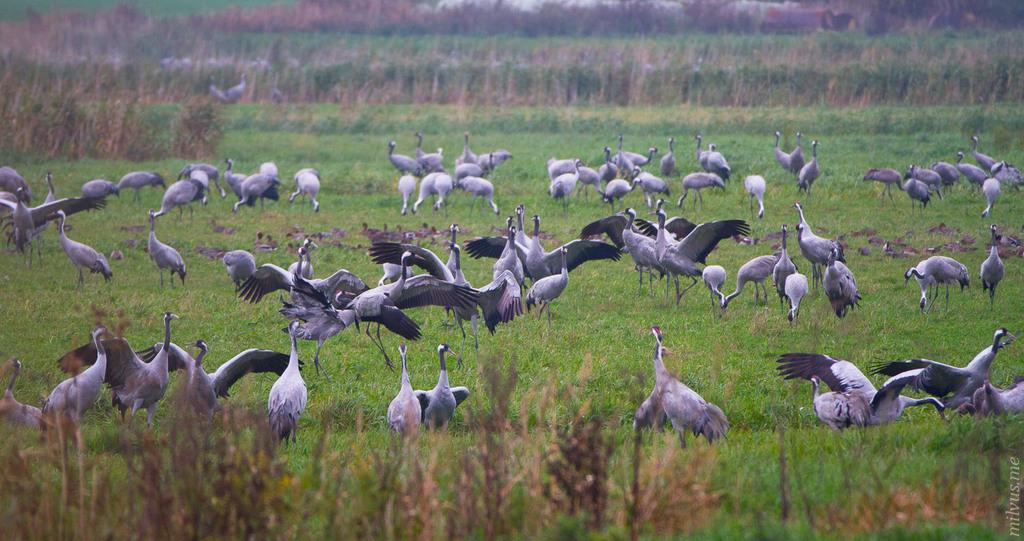What is located in the center of the image? There are birds in the center of the image. What type of surface is visible on the ground in the image? There is grass on the ground in the image. What can be seen in the background of the image? There are plants in the background of the image. What decision did the actor make in the image? There is no actor or decision-making process depicted in the image; it features birds, grass, and plants. 